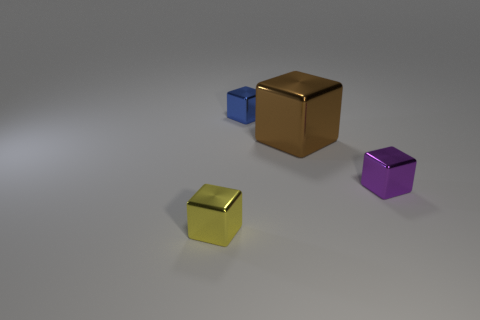Is there anything else that has the same size as the brown metallic object?
Your answer should be compact. No. What color is the large metal object that is the same shape as the small yellow shiny object?
Keep it short and to the point. Brown. Do the purple metal block and the brown shiny cube have the same size?
Keep it short and to the point. No. Is the number of small blue blocks that are in front of the blue shiny object the same as the number of small metal blocks behind the big brown shiny thing?
Keep it short and to the point. No. Is there a small metal thing?
Offer a very short reply. Yes. What is the size of the purple object that is the same shape as the brown metal object?
Provide a short and direct response. Small. There is a metallic cube in front of the purple object; what size is it?
Keep it short and to the point. Small. Are there more cubes behind the yellow thing than purple matte objects?
Your response must be concise. Yes. What is the shape of the brown shiny object?
Your answer should be compact. Cube. Is the large brown shiny thing the same shape as the tiny blue metallic thing?
Make the answer very short. Yes. 